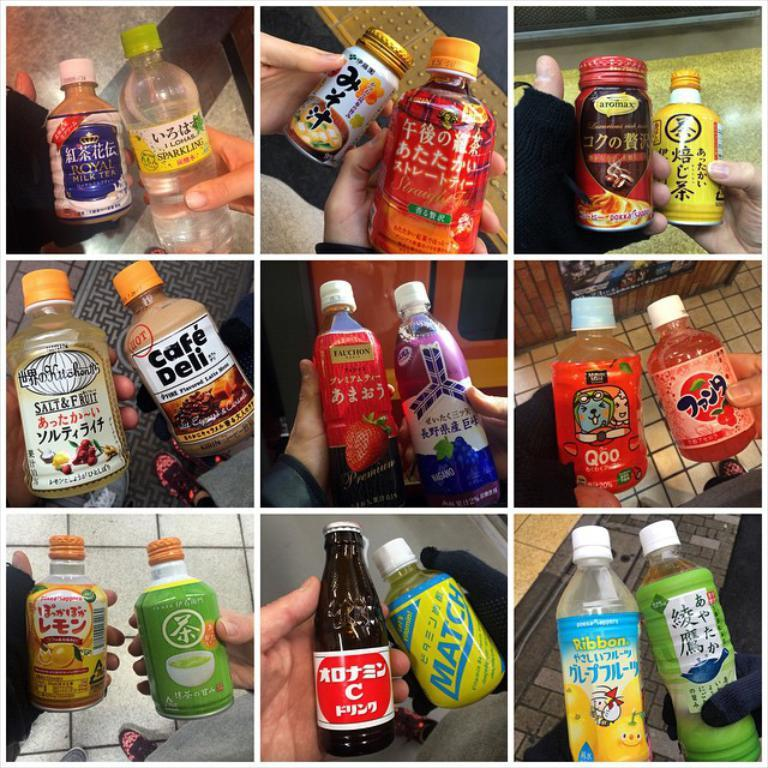How many images are included in the collage? The collage contains six images. What is the subject of each image in the collage? Each image features a different soft drink. Can you identify the brands of the soft drinks in the collage? Yes, each soft drink has a different brand. Who is holding each soft drink in the images? Each soft drink is held by a different person. What role does the queen play in the collage? There is no queen present in the collage; it features images of people holding different soft drinks. How many women are visible in the collage? The collage does not specify the gender of the people holding the soft drinks, so it is not possible to determine the number of women in the collage. 